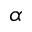Convert formula to latex. <formula><loc_0><loc_0><loc_500><loc_500>\alpha</formula> 